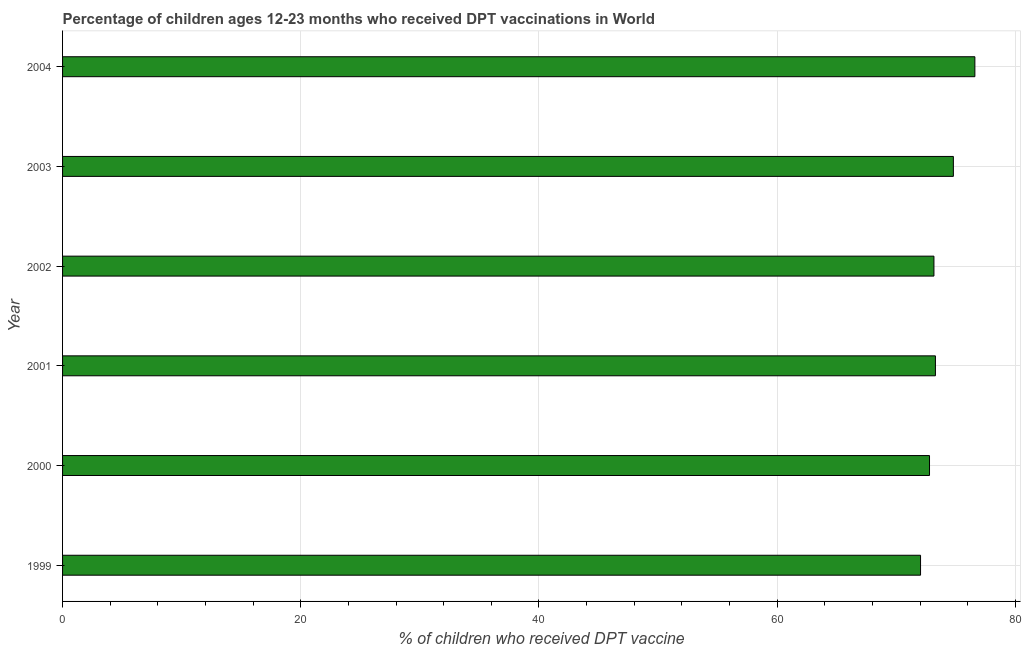What is the title of the graph?
Your answer should be very brief. Percentage of children ages 12-23 months who received DPT vaccinations in World. What is the label or title of the X-axis?
Keep it short and to the point. % of children who received DPT vaccine. What is the label or title of the Y-axis?
Provide a succinct answer. Year. What is the percentage of children who received dpt vaccine in 2002?
Your answer should be very brief. 73.17. Across all years, what is the maximum percentage of children who received dpt vaccine?
Your response must be concise. 76.6. Across all years, what is the minimum percentage of children who received dpt vaccine?
Offer a very short reply. 72.04. What is the sum of the percentage of children who received dpt vaccine?
Ensure brevity in your answer.  442.7. What is the difference between the percentage of children who received dpt vaccine in 2000 and 2004?
Your answer should be compact. -3.81. What is the average percentage of children who received dpt vaccine per year?
Your response must be concise. 73.78. What is the median percentage of children who received dpt vaccine?
Offer a terse response. 73.23. In how many years, is the percentage of children who received dpt vaccine greater than 28 %?
Offer a very short reply. 6. Do a majority of the years between 2003 and 2001 (inclusive) have percentage of children who received dpt vaccine greater than 64 %?
Your answer should be compact. Yes. Is the percentage of children who received dpt vaccine in 2002 less than that in 2004?
Make the answer very short. Yes. What is the difference between the highest and the second highest percentage of children who received dpt vaccine?
Make the answer very short. 1.81. What is the difference between the highest and the lowest percentage of children who received dpt vaccine?
Provide a succinct answer. 4.56. In how many years, is the percentage of children who received dpt vaccine greater than the average percentage of children who received dpt vaccine taken over all years?
Your answer should be compact. 2. How many bars are there?
Offer a very short reply. 6. Are all the bars in the graph horizontal?
Offer a terse response. Yes. How many years are there in the graph?
Give a very brief answer. 6. What is the difference between two consecutive major ticks on the X-axis?
Provide a short and direct response. 20. What is the % of children who received DPT vaccine of 1999?
Make the answer very short. 72.04. What is the % of children who received DPT vaccine in 2000?
Make the answer very short. 72.8. What is the % of children who received DPT vaccine of 2001?
Your answer should be very brief. 73.29. What is the % of children who received DPT vaccine in 2002?
Your answer should be compact. 73.17. What is the % of children who received DPT vaccine in 2003?
Make the answer very short. 74.8. What is the % of children who received DPT vaccine of 2004?
Keep it short and to the point. 76.6. What is the difference between the % of children who received DPT vaccine in 1999 and 2000?
Give a very brief answer. -0.75. What is the difference between the % of children who received DPT vaccine in 1999 and 2001?
Your answer should be very brief. -1.25. What is the difference between the % of children who received DPT vaccine in 1999 and 2002?
Make the answer very short. -1.13. What is the difference between the % of children who received DPT vaccine in 1999 and 2003?
Your response must be concise. -2.76. What is the difference between the % of children who received DPT vaccine in 1999 and 2004?
Make the answer very short. -4.56. What is the difference between the % of children who received DPT vaccine in 2000 and 2001?
Make the answer very short. -0.5. What is the difference between the % of children who received DPT vaccine in 2000 and 2002?
Ensure brevity in your answer.  -0.37. What is the difference between the % of children who received DPT vaccine in 2000 and 2003?
Offer a very short reply. -2. What is the difference between the % of children who received DPT vaccine in 2000 and 2004?
Give a very brief answer. -3.81. What is the difference between the % of children who received DPT vaccine in 2001 and 2002?
Provide a succinct answer. 0.12. What is the difference between the % of children who received DPT vaccine in 2001 and 2003?
Offer a very short reply. -1.51. What is the difference between the % of children who received DPT vaccine in 2001 and 2004?
Ensure brevity in your answer.  -3.31. What is the difference between the % of children who received DPT vaccine in 2002 and 2003?
Give a very brief answer. -1.63. What is the difference between the % of children who received DPT vaccine in 2002 and 2004?
Provide a succinct answer. -3.44. What is the difference between the % of children who received DPT vaccine in 2003 and 2004?
Your answer should be compact. -1.81. What is the ratio of the % of children who received DPT vaccine in 1999 to that in 2000?
Provide a succinct answer. 0.99. What is the ratio of the % of children who received DPT vaccine in 1999 to that in 2002?
Keep it short and to the point. 0.98. What is the ratio of the % of children who received DPT vaccine in 1999 to that in 2003?
Keep it short and to the point. 0.96. What is the ratio of the % of children who received DPT vaccine in 1999 to that in 2004?
Keep it short and to the point. 0.94. What is the ratio of the % of children who received DPT vaccine in 2000 to that in 2004?
Give a very brief answer. 0.95. What is the ratio of the % of children who received DPT vaccine in 2001 to that in 2003?
Offer a very short reply. 0.98. What is the ratio of the % of children who received DPT vaccine in 2002 to that in 2003?
Offer a very short reply. 0.98. What is the ratio of the % of children who received DPT vaccine in 2002 to that in 2004?
Offer a very short reply. 0.95. What is the ratio of the % of children who received DPT vaccine in 2003 to that in 2004?
Provide a succinct answer. 0.98. 